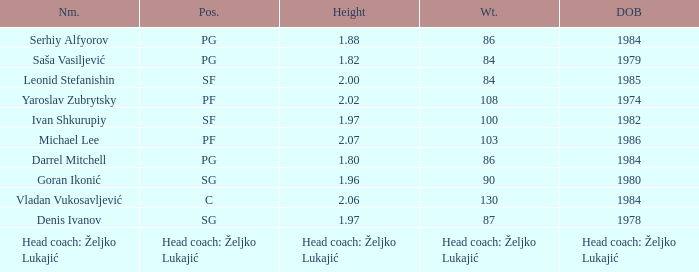What is the weight of the person born in 1980? 90.0. 